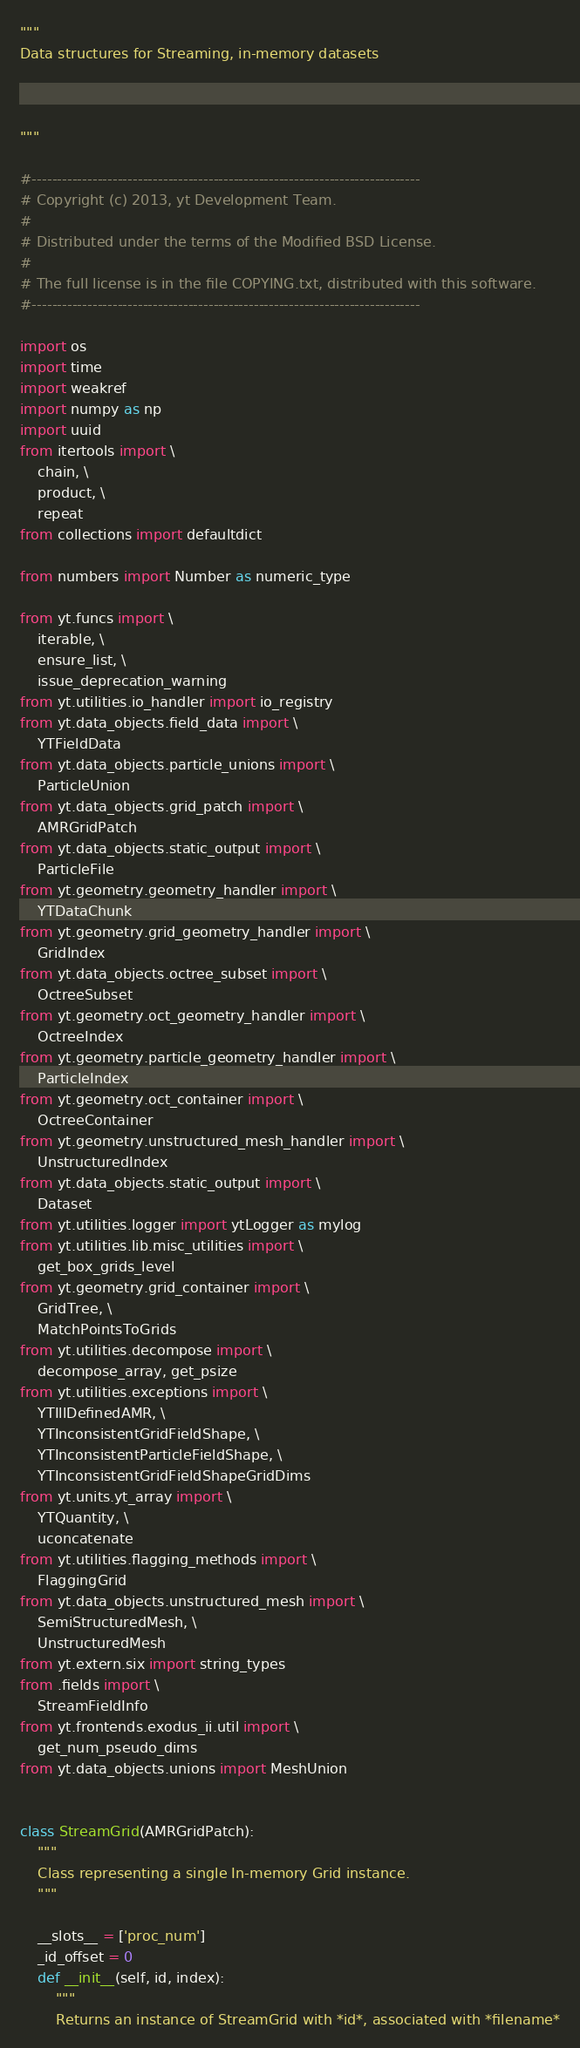Convert code to text. <code><loc_0><loc_0><loc_500><loc_500><_Python_>"""
Data structures for Streaming, in-memory datasets



"""

#-----------------------------------------------------------------------------
# Copyright (c) 2013, yt Development Team.
#
# Distributed under the terms of the Modified BSD License.
#
# The full license is in the file COPYING.txt, distributed with this software.
#-----------------------------------------------------------------------------

import os
import time
import weakref
import numpy as np
import uuid
from itertools import \
    chain, \
    product, \
    repeat
from collections import defaultdict

from numbers import Number as numeric_type

from yt.funcs import \
    iterable, \
    ensure_list, \
    issue_deprecation_warning
from yt.utilities.io_handler import io_registry
from yt.data_objects.field_data import \
    YTFieldData
from yt.data_objects.particle_unions import \
    ParticleUnion
from yt.data_objects.grid_patch import \
    AMRGridPatch
from yt.data_objects.static_output import \
    ParticleFile
from yt.geometry.geometry_handler import \
    YTDataChunk
from yt.geometry.grid_geometry_handler import \
    GridIndex
from yt.data_objects.octree_subset import \
    OctreeSubset
from yt.geometry.oct_geometry_handler import \
    OctreeIndex
from yt.geometry.particle_geometry_handler import \
    ParticleIndex
from yt.geometry.oct_container import \
    OctreeContainer
from yt.geometry.unstructured_mesh_handler import \
    UnstructuredIndex
from yt.data_objects.static_output import \
    Dataset
from yt.utilities.logger import ytLogger as mylog
from yt.utilities.lib.misc_utilities import \
    get_box_grids_level
from yt.geometry.grid_container import \
    GridTree, \
    MatchPointsToGrids
from yt.utilities.decompose import \
    decompose_array, get_psize
from yt.utilities.exceptions import \
    YTIllDefinedAMR, \
    YTInconsistentGridFieldShape, \
    YTInconsistentParticleFieldShape, \
    YTInconsistentGridFieldShapeGridDims
from yt.units.yt_array import \
    YTQuantity, \
    uconcatenate
from yt.utilities.flagging_methods import \
    FlaggingGrid
from yt.data_objects.unstructured_mesh import \
    SemiStructuredMesh, \
    UnstructuredMesh
from yt.extern.six import string_types
from .fields import \
    StreamFieldInfo
from yt.frontends.exodus_ii.util import \
    get_num_pseudo_dims
from yt.data_objects.unions import MeshUnion


class StreamGrid(AMRGridPatch):
    """
    Class representing a single In-memory Grid instance.
    """

    __slots__ = ['proc_num']
    _id_offset = 0
    def __init__(self, id, index):
        """
        Returns an instance of StreamGrid with *id*, associated with *filename*</code> 